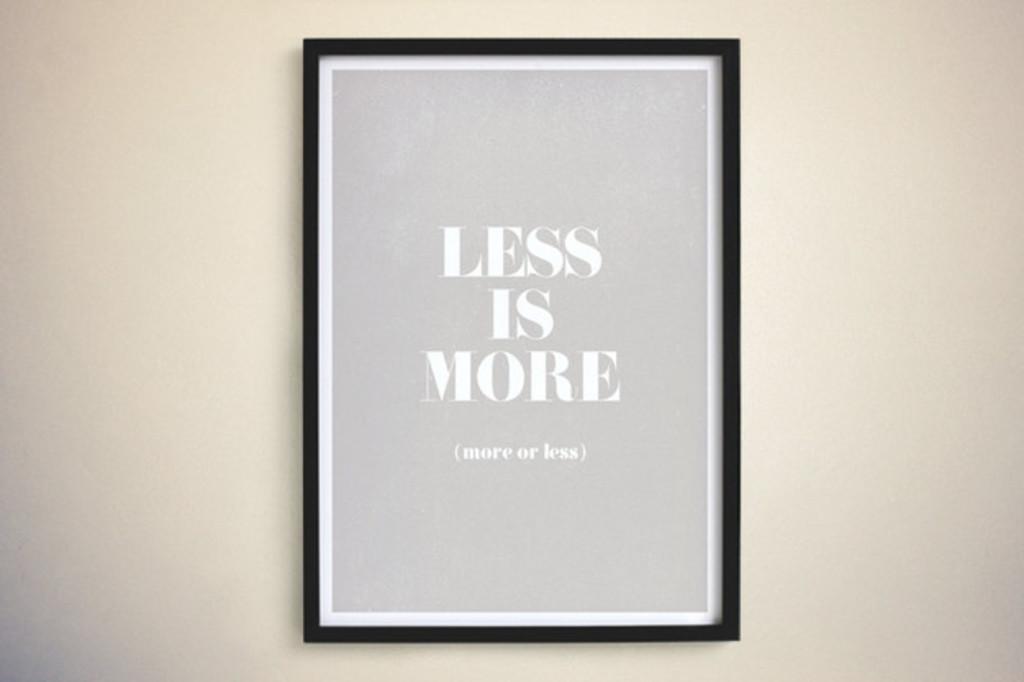What is more?
Your answer should be very brief. Less. What is more?
Provide a short and direct response. Less. 